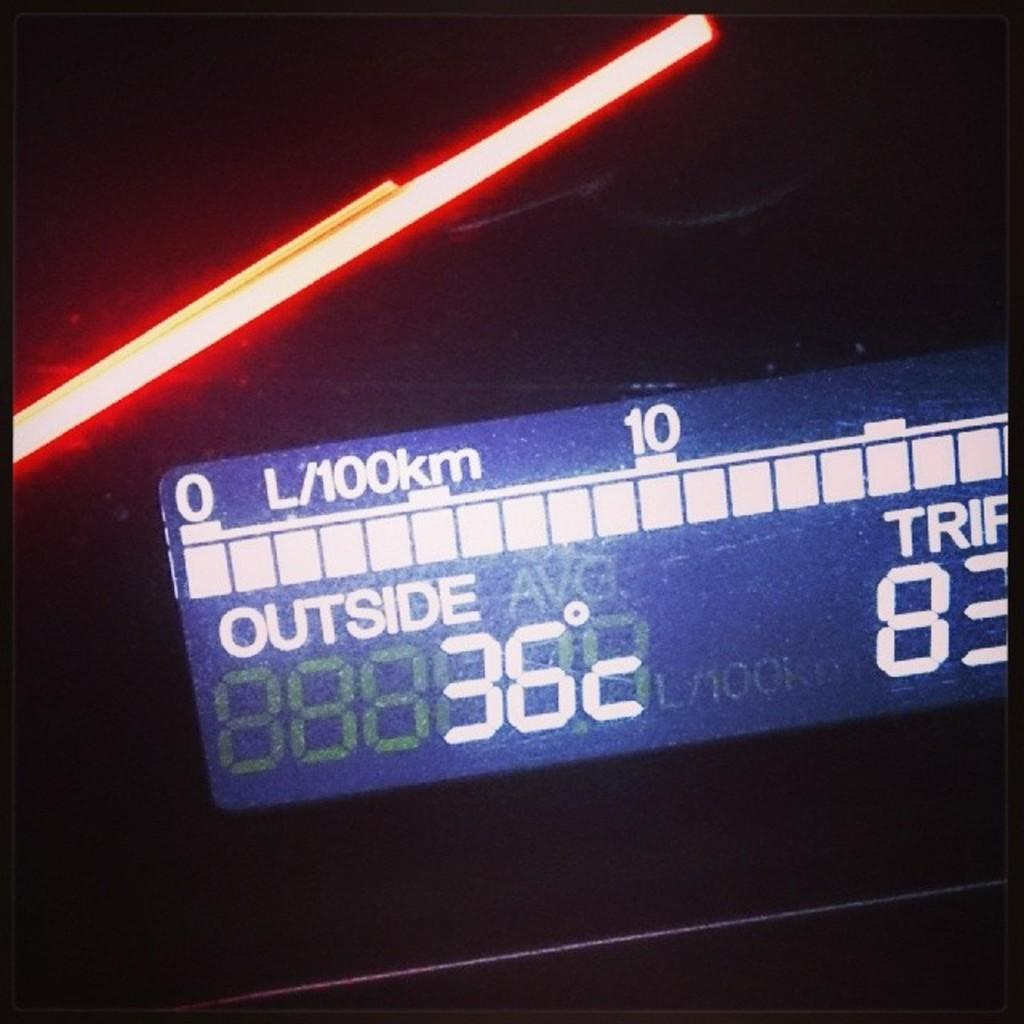<image>
Write a terse but informative summary of the picture. A screen displays the outside temperature of 36 degrees C. 